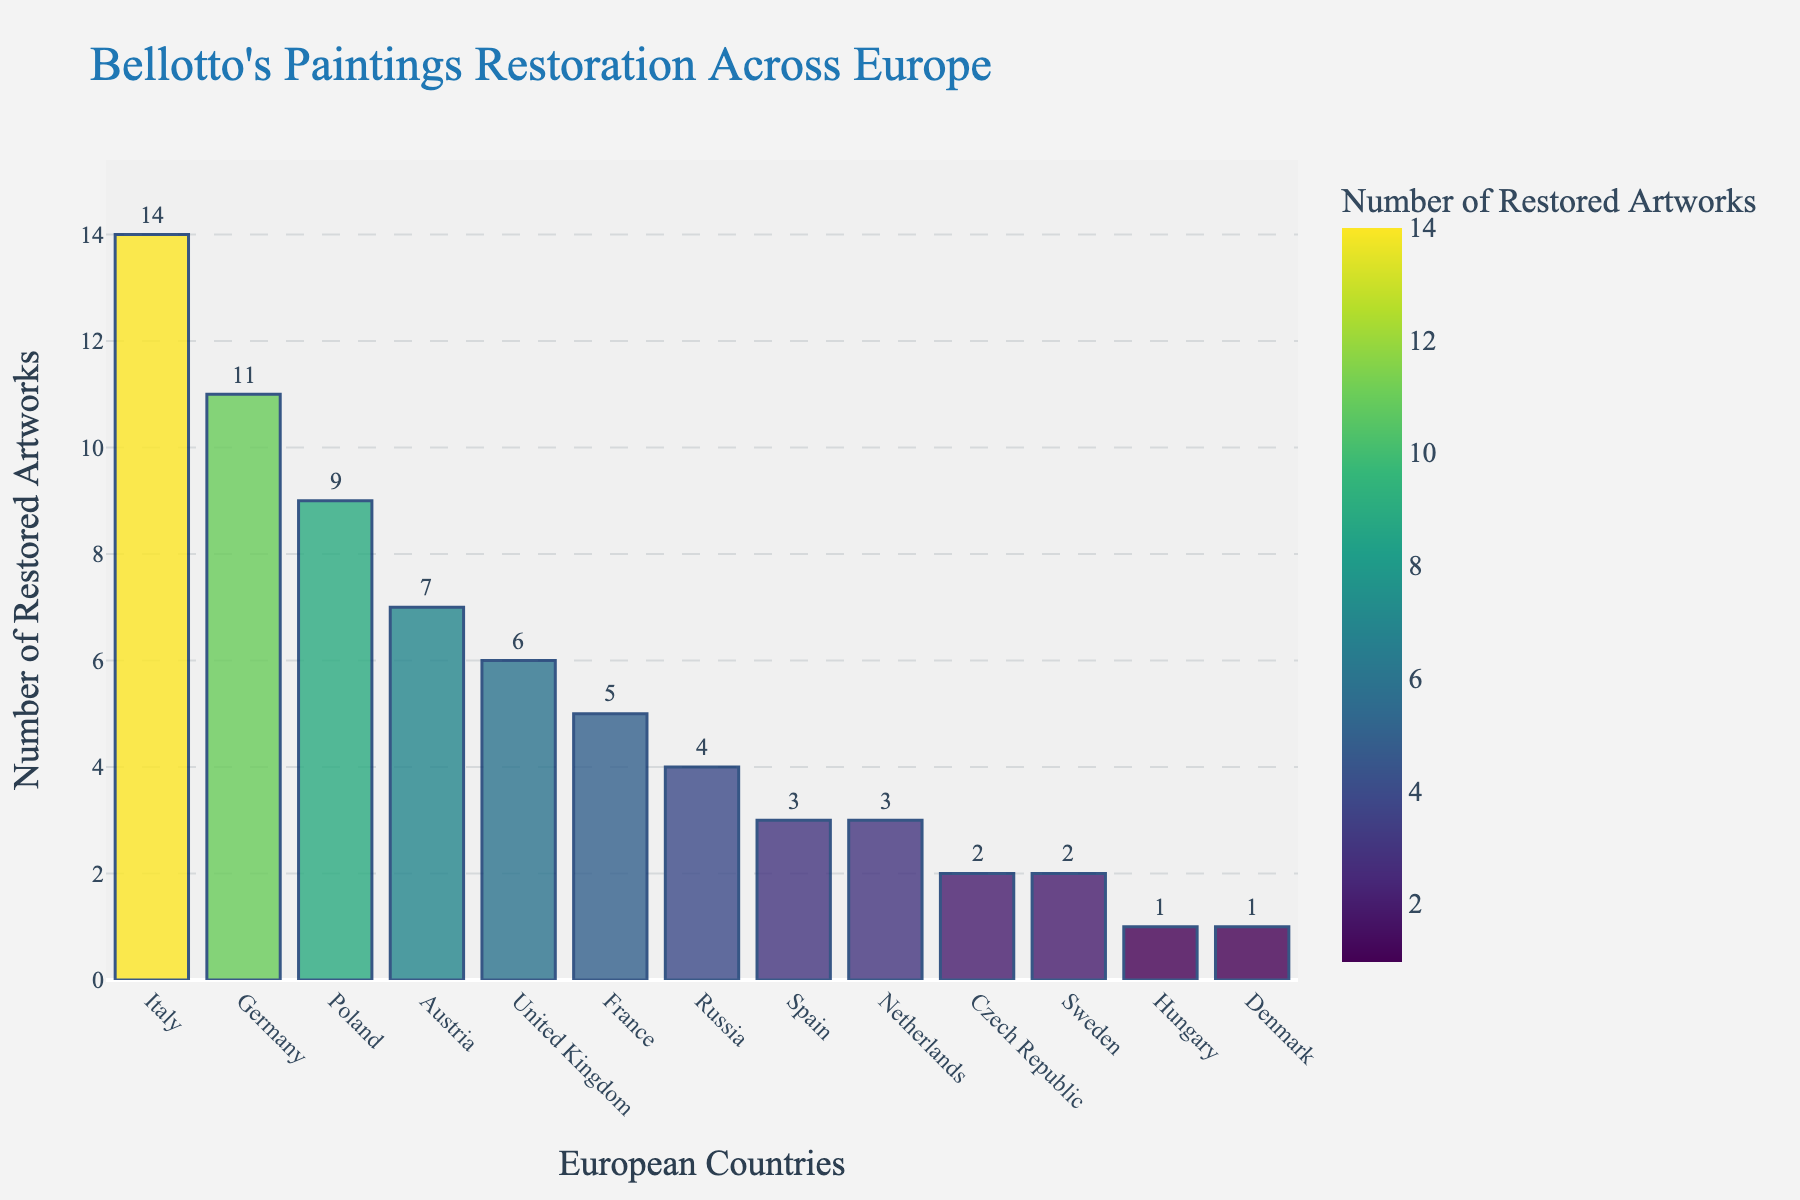Which country has restored the most Bellotto paintings? By looking at the bar chart, Italy has the tallest bar, indicating it has restored the most Bellotto paintings.
Answer: Italy Which country has the fewest number of restored Bellotto paintings? Denmark and Hungary have the smallest bars, each representing the least number of restored paintings.
Answer: Denmark, Hungary What is the total number of Bellotto paintings restored across Germany and Poland? Germany has 11 restored artworks, and Poland has 9. Adding them, 11 + 9 = 20.
Answer: 20 How many more paintings has Italy restored compared to Austria? Italy has 14 restored paintings and Austria has 7, the difference is 14 - 7 = 7.
Answer: 7 Which countries have restored fewer than 5 Bellotto paintings? By examining the bar heights, Russia, Spain, Netherlands, Czech Republic, Sweden, Hungary, and Denmark have bars representing fewer than 5 paintings.
Answer: Russia, Spain, Netherlands, Czech Republic, Sweden, Hungary, Denmark What is the average number of Bellotto paintings restored in all the listed countries? To find the average, sum all the restored artworks (14 + 11 + 9 + 7 + 6 + 5 + 4 + 3 + 3 + 2 + 2 + 1 + 1 = 68), then divide by the number of countries (13). 68 / 13 ≈ 5.23.
Answer: 5.23 How many more Bellotto paintings has Italy restored compared to the United Kingdom? Italy has 14 restored paintings and the United Kingdom has 6, the difference is 14 - 6 = 8.
Answer: 8 Which three countries have restored the highest number of Bellotto paintings? The tallest bars correspond to Italy (14), Germany (11), and Poland (9).
Answer: Italy, Germany, Poland What is the combined total of Bellotto paintings restored by France and Spain? France has 5 restored paintings, and Spain has 3. The combined total is 5 + 3 = 8.
Answer: 8 